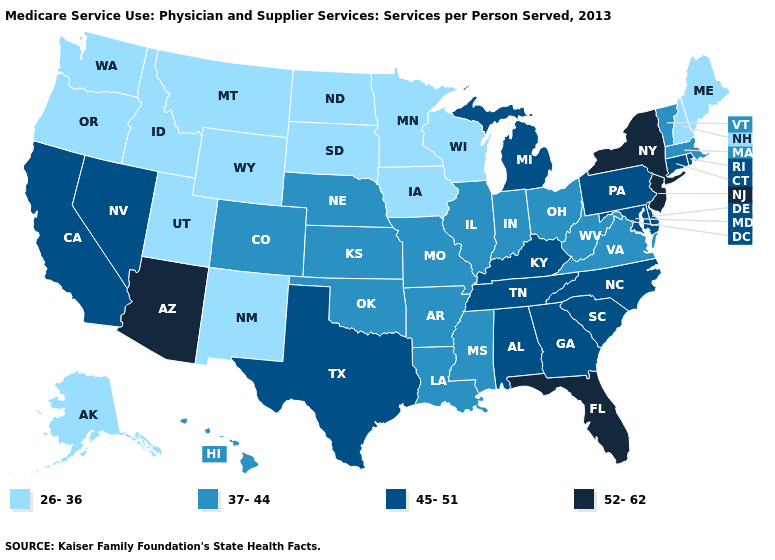Does the map have missing data?
Quick response, please. No. Does New Jersey have the highest value in the USA?
Answer briefly. Yes. Does Tennessee have the same value as Maine?
Short answer required. No. Among the states that border Maine , which have the highest value?
Concise answer only. New Hampshire. Name the states that have a value in the range 45-51?
Short answer required. Alabama, California, Connecticut, Delaware, Georgia, Kentucky, Maryland, Michigan, Nevada, North Carolina, Pennsylvania, Rhode Island, South Carolina, Tennessee, Texas. Does Utah have the highest value in the West?
Quick response, please. No. Name the states that have a value in the range 45-51?
Quick response, please. Alabama, California, Connecticut, Delaware, Georgia, Kentucky, Maryland, Michigan, Nevada, North Carolina, Pennsylvania, Rhode Island, South Carolina, Tennessee, Texas. What is the value of Vermont?
Write a very short answer. 37-44. Name the states that have a value in the range 37-44?
Quick response, please. Arkansas, Colorado, Hawaii, Illinois, Indiana, Kansas, Louisiana, Massachusetts, Mississippi, Missouri, Nebraska, Ohio, Oklahoma, Vermont, Virginia, West Virginia. What is the value of South Dakota?
Answer briefly. 26-36. What is the value of Maryland?
Short answer required. 45-51. What is the highest value in states that border Connecticut?
Write a very short answer. 52-62. Which states hav the highest value in the MidWest?
Short answer required. Michigan. What is the lowest value in states that border Mississippi?
Short answer required. 37-44. Name the states that have a value in the range 26-36?
Give a very brief answer. Alaska, Idaho, Iowa, Maine, Minnesota, Montana, New Hampshire, New Mexico, North Dakota, Oregon, South Dakota, Utah, Washington, Wisconsin, Wyoming. 